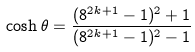<formula> <loc_0><loc_0><loc_500><loc_500>\cosh \theta = \frac { ( 8 ^ { 2 k + 1 } - 1 ) ^ { 2 } + 1 } { ( 8 ^ { 2 k + 1 } - 1 ) ^ { 2 } - 1 }</formula> 